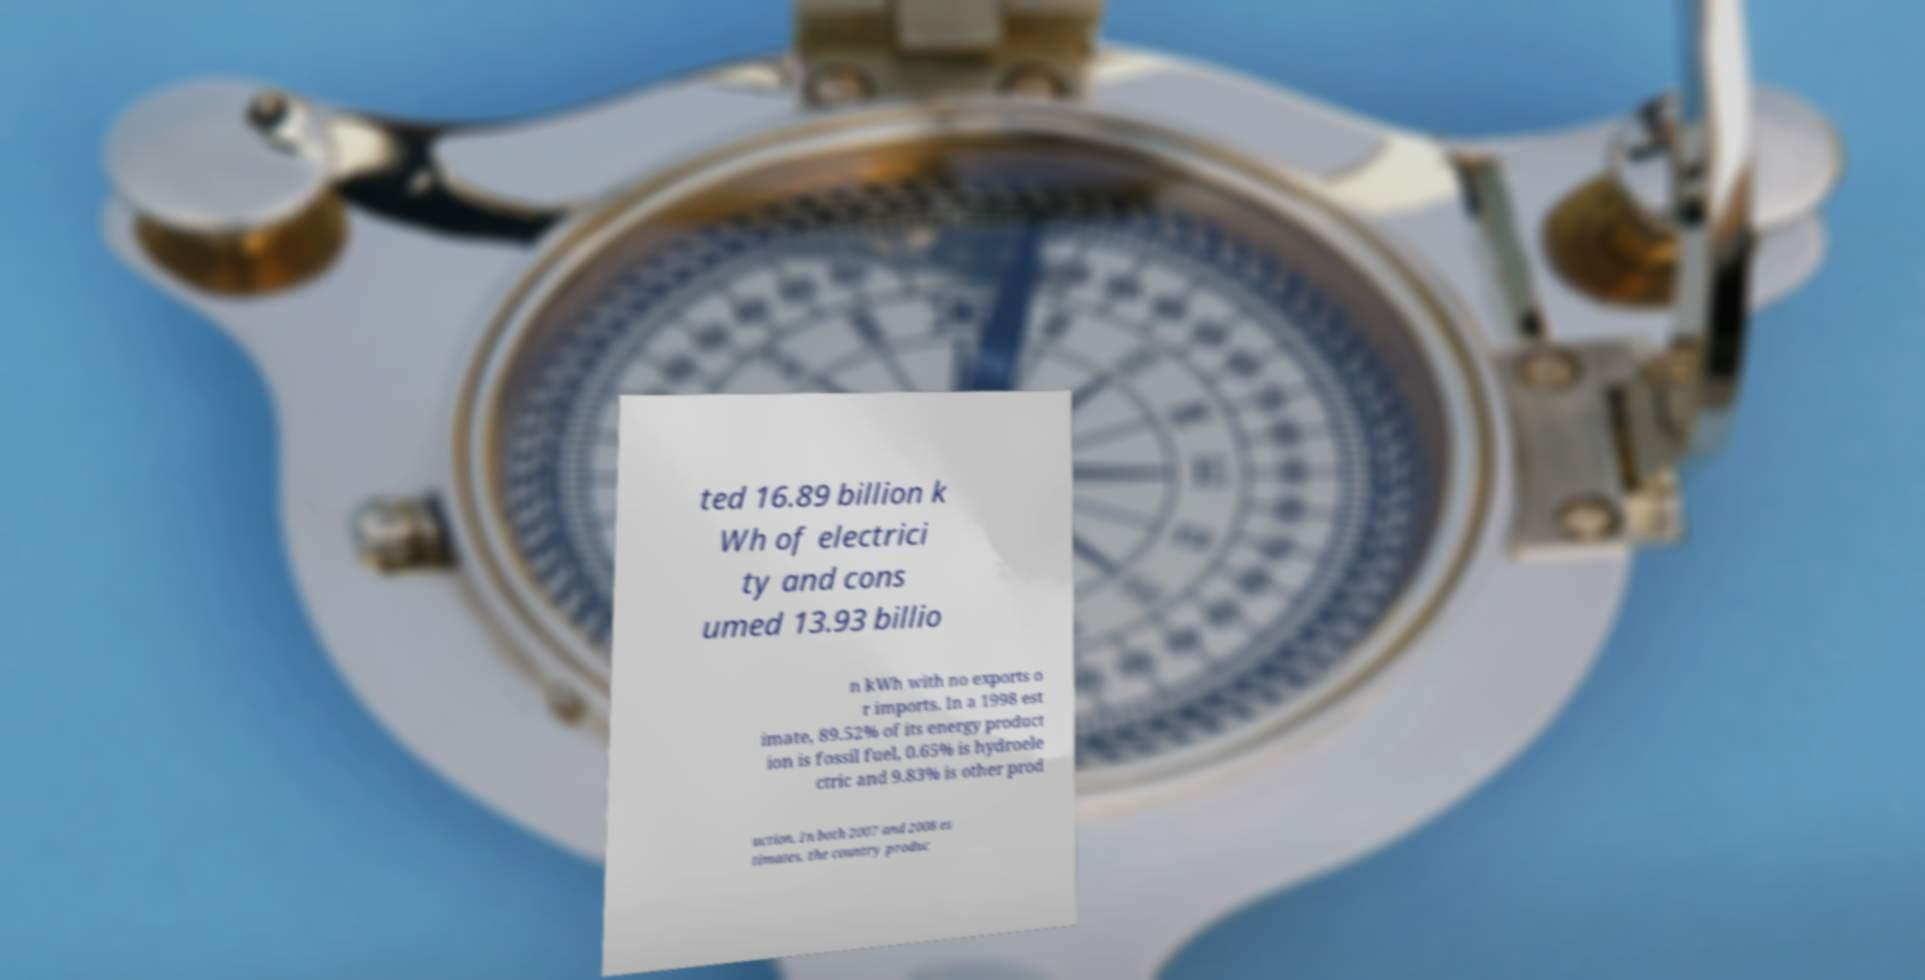There's text embedded in this image that I need extracted. Can you transcribe it verbatim? ted 16.89 billion k Wh of electrici ty and cons umed 13.93 billio n kWh with no exports o r imports. In a 1998 est imate, 89.52% of its energy product ion is fossil fuel, 0.65% is hydroele ctric and 9.83% is other prod uction. In both 2007 and 2008 es timates, the country produc 